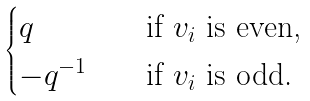<formula> <loc_0><loc_0><loc_500><loc_500>\begin{cases} q & \quad \text {if $v_{i}$ is even,} \\ - q ^ { - 1 } & \quad \text {if $v_{i}$ is odd.} \end{cases}</formula> 